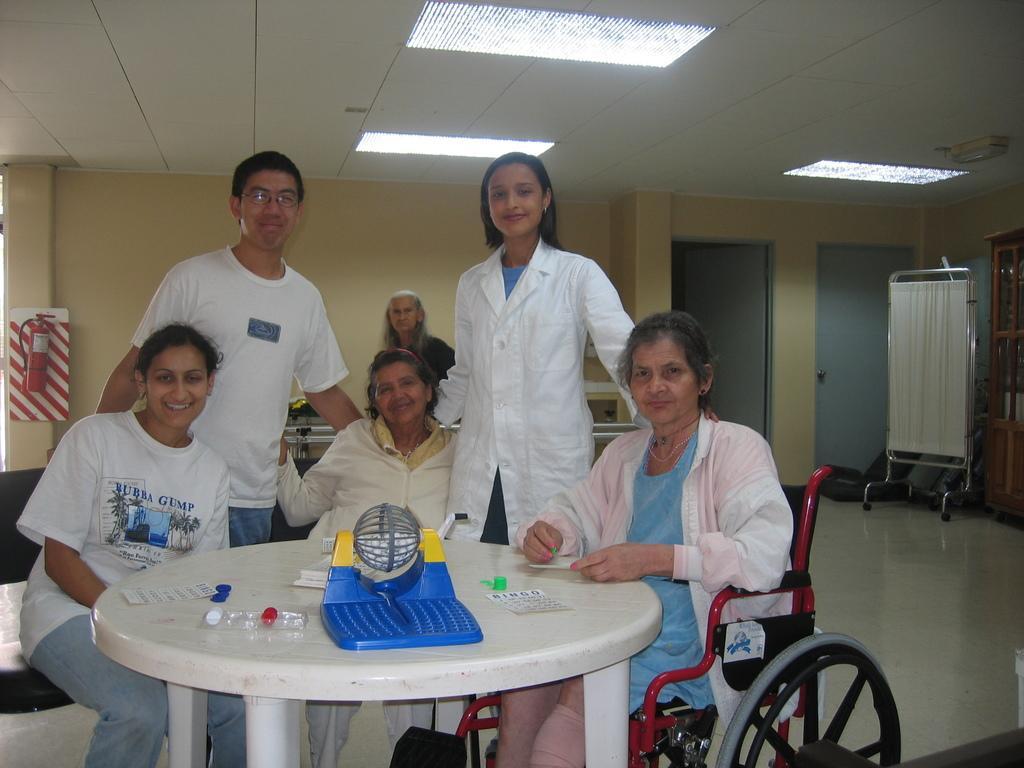Please provide a concise description of this image. As we can see in the image there is yellow color wall, a cloth, few people sitting and standing over here and there is a table in the front. On table there is a tablet sheet. 